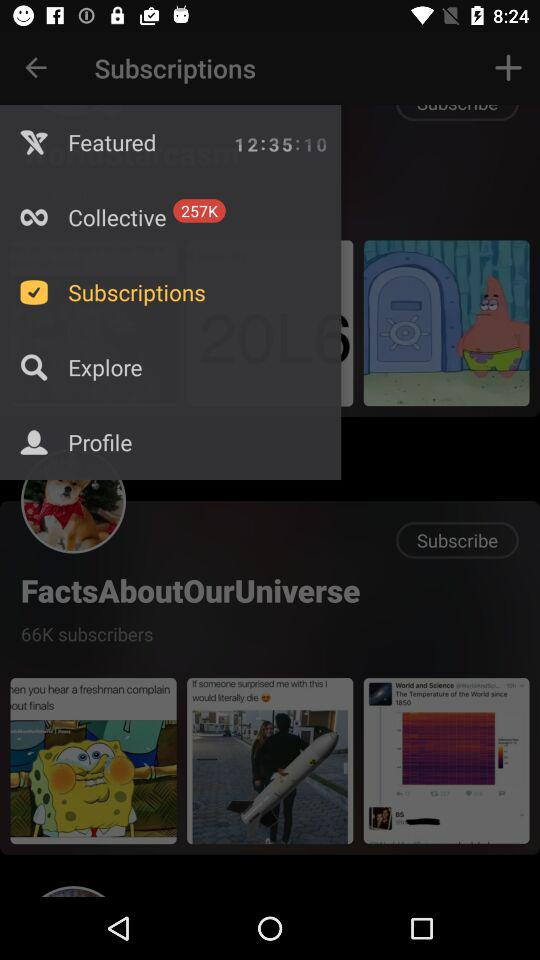How many points are there in the "Collective" option? There are 257K points. 